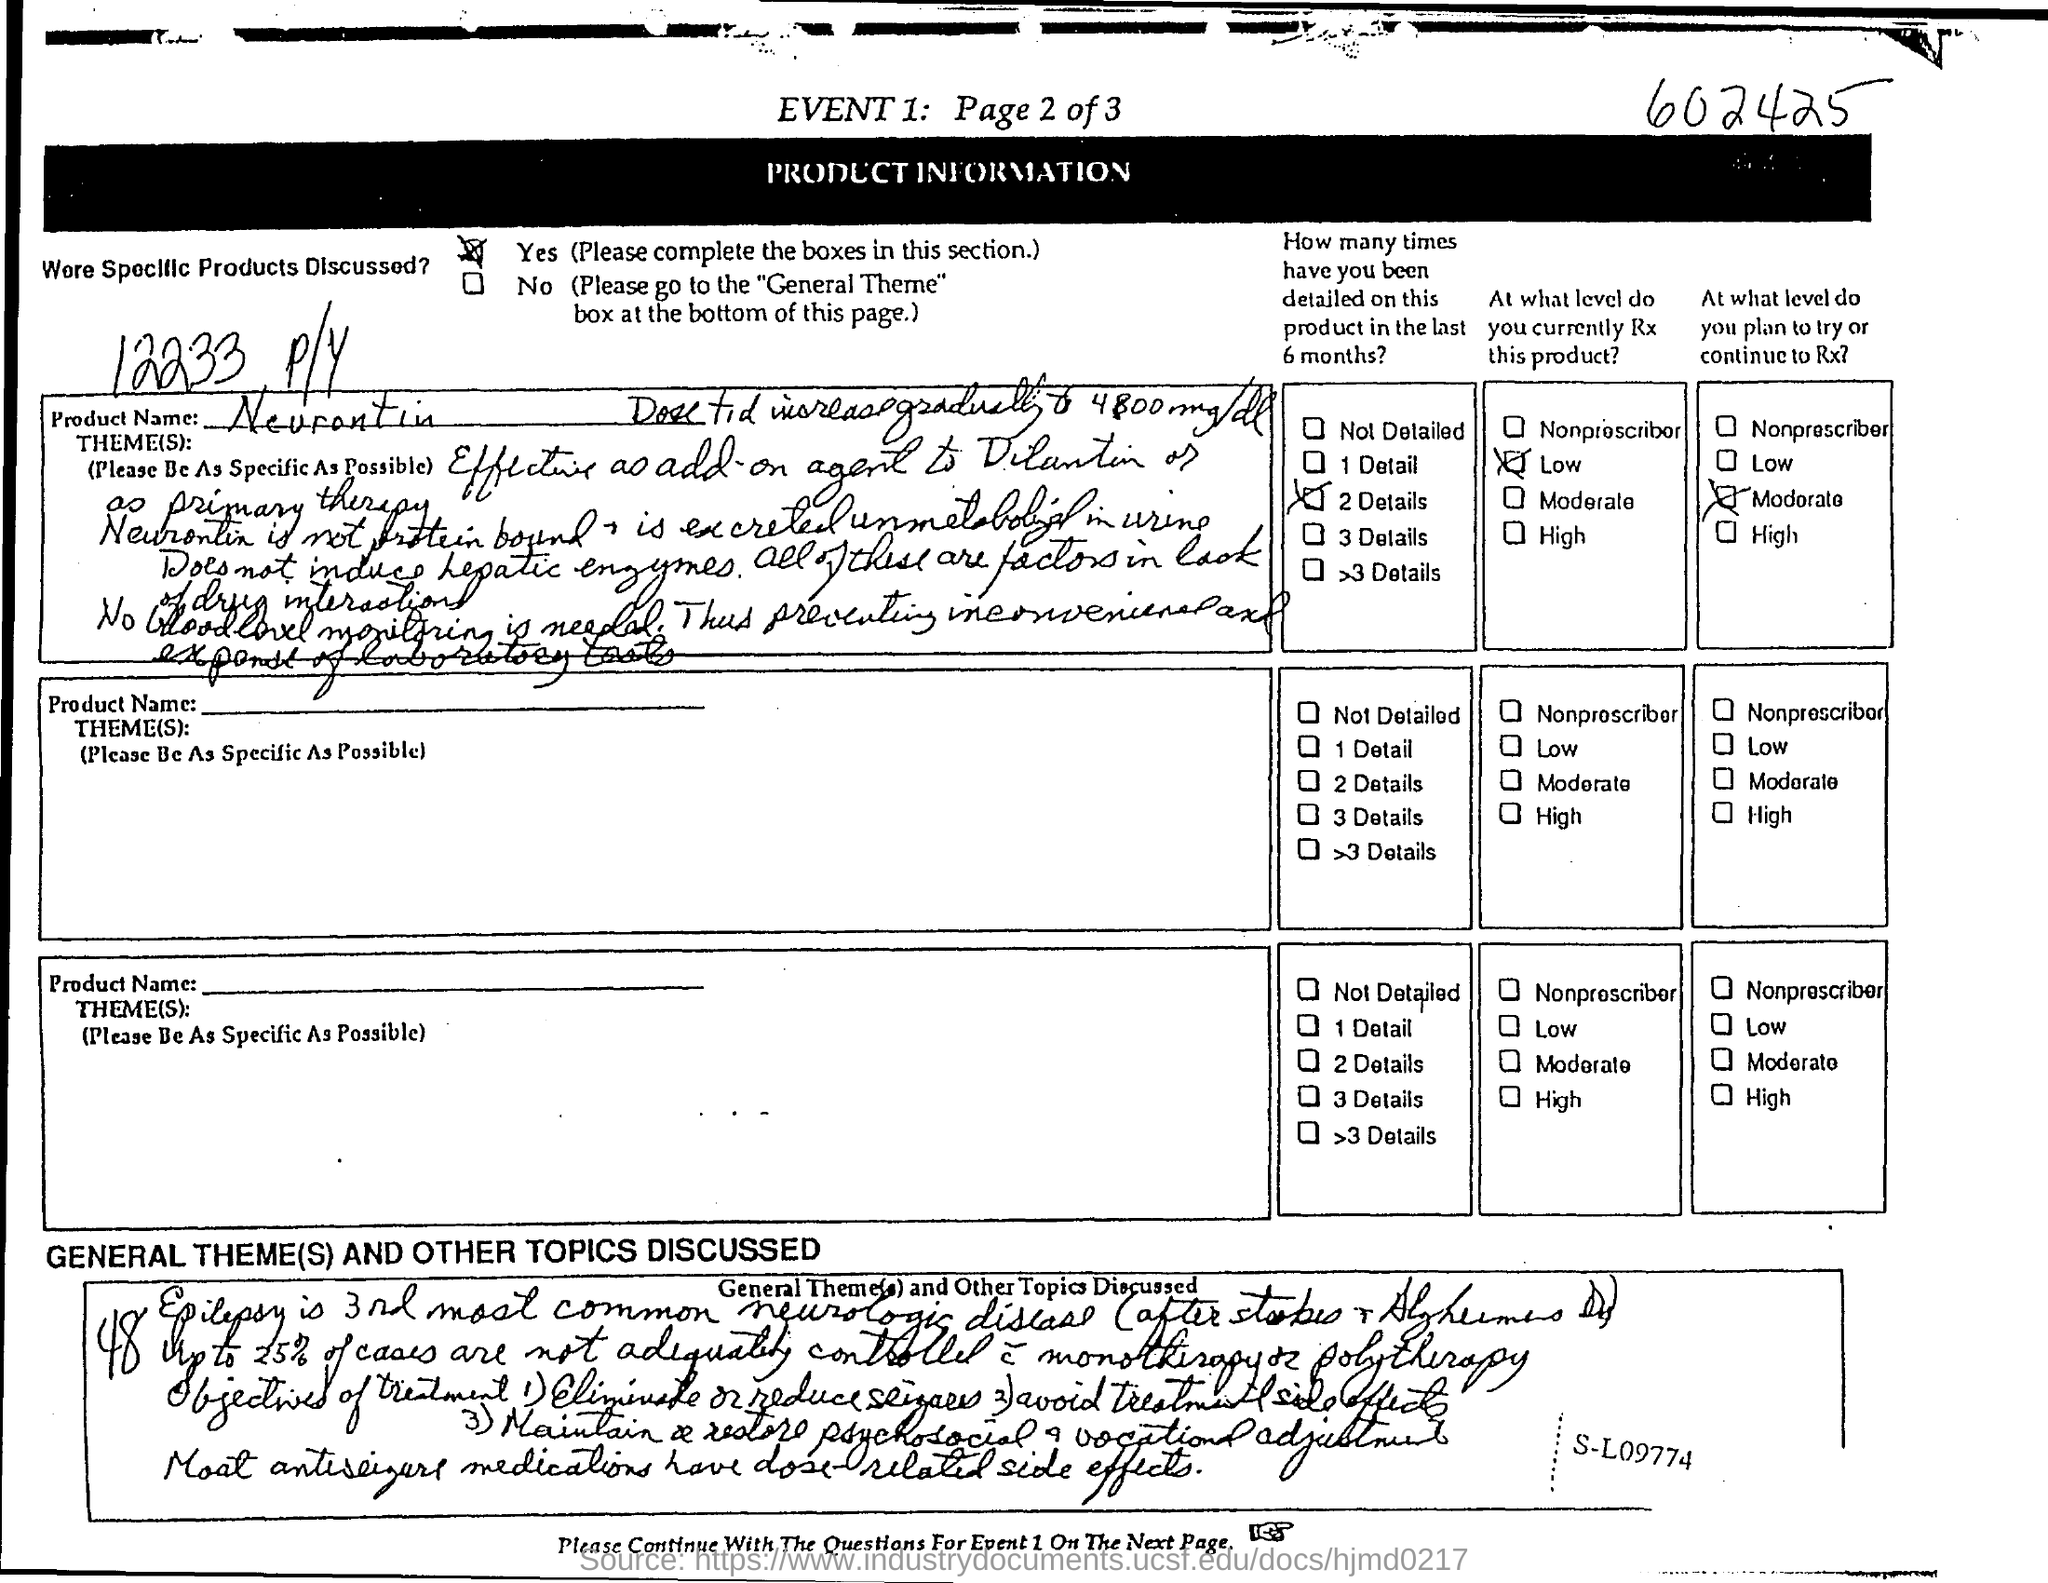What is the product name ?
Your response must be concise. Neurontin. 